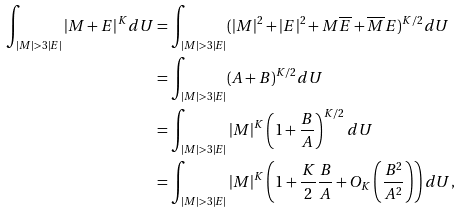Convert formula to latex. <formula><loc_0><loc_0><loc_500><loc_500>\int _ { | M | > 3 | E | } | M + E | ^ { K } d U & = \int _ { | M | > 3 | E | } ( | M | ^ { 2 } + | E | ^ { 2 } + M \overline { E } + \overline { M } E ) ^ { K / 2 } d U \\ & = \int _ { | M | > 3 | E | } ( A + B ) ^ { K / 2 } d U \\ & = \int _ { | M | > 3 | E | } | M | ^ { K } \left ( 1 + \frac { B } { A } \right ) ^ { K / 2 } d U \\ & = \int _ { | M | > 3 | E | } | M | ^ { K } \left ( 1 + \frac { K } { 2 } \frac { B } { A } + O _ { K } \left ( \frac { B ^ { 2 } } { A ^ { 2 } } \right ) \right ) d U ,</formula> 